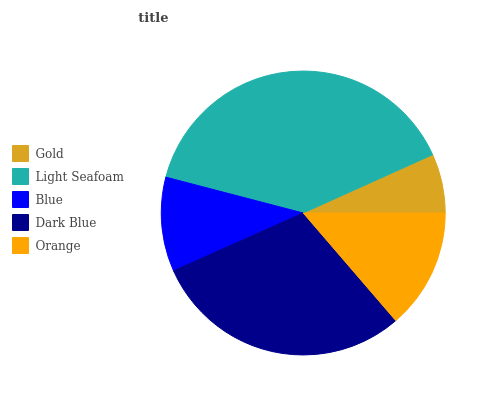Is Gold the minimum?
Answer yes or no. Yes. Is Light Seafoam the maximum?
Answer yes or no. Yes. Is Blue the minimum?
Answer yes or no. No. Is Blue the maximum?
Answer yes or no. No. Is Light Seafoam greater than Blue?
Answer yes or no. Yes. Is Blue less than Light Seafoam?
Answer yes or no. Yes. Is Blue greater than Light Seafoam?
Answer yes or no. No. Is Light Seafoam less than Blue?
Answer yes or no. No. Is Orange the high median?
Answer yes or no. Yes. Is Orange the low median?
Answer yes or no. Yes. Is Blue the high median?
Answer yes or no. No. Is Blue the low median?
Answer yes or no. No. 